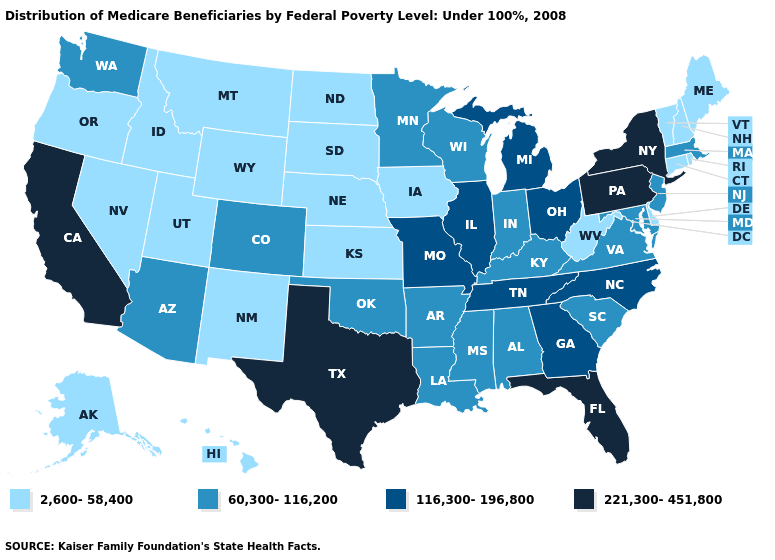Which states hav the highest value in the South?
Keep it brief. Florida, Texas. How many symbols are there in the legend?
Concise answer only. 4. Which states have the lowest value in the USA?
Concise answer only. Alaska, Connecticut, Delaware, Hawaii, Idaho, Iowa, Kansas, Maine, Montana, Nebraska, Nevada, New Hampshire, New Mexico, North Dakota, Oregon, Rhode Island, South Dakota, Utah, Vermont, West Virginia, Wyoming. What is the lowest value in the MidWest?
Write a very short answer. 2,600-58,400. Among the states that border Nebraska , which have the lowest value?
Keep it brief. Iowa, Kansas, South Dakota, Wyoming. Name the states that have a value in the range 221,300-451,800?
Short answer required. California, Florida, New York, Pennsylvania, Texas. Does Washington have a lower value than Kansas?
Quick response, please. No. What is the highest value in states that border Utah?
Write a very short answer. 60,300-116,200. Does the map have missing data?
Give a very brief answer. No. Name the states that have a value in the range 2,600-58,400?
Write a very short answer. Alaska, Connecticut, Delaware, Hawaii, Idaho, Iowa, Kansas, Maine, Montana, Nebraska, Nevada, New Hampshire, New Mexico, North Dakota, Oregon, Rhode Island, South Dakota, Utah, Vermont, West Virginia, Wyoming. What is the value of Hawaii?
Write a very short answer. 2,600-58,400. Does Iowa have the highest value in the MidWest?
Concise answer only. No. What is the value of Pennsylvania?
Give a very brief answer. 221,300-451,800. What is the lowest value in states that border New Hampshire?
Short answer required. 2,600-58,400. Name the states that have a value in the range 60,300-116,200?
Concise answer only. Alabama, Arizona, Arkansas, Colorado, Indiana, Kentucky, Louisiana, Maryland, Massachusetts, Minnesota, Mississippi, New Jersey, Oklahoma, South Carolina, Virginia, Washington, Wisconsin. 